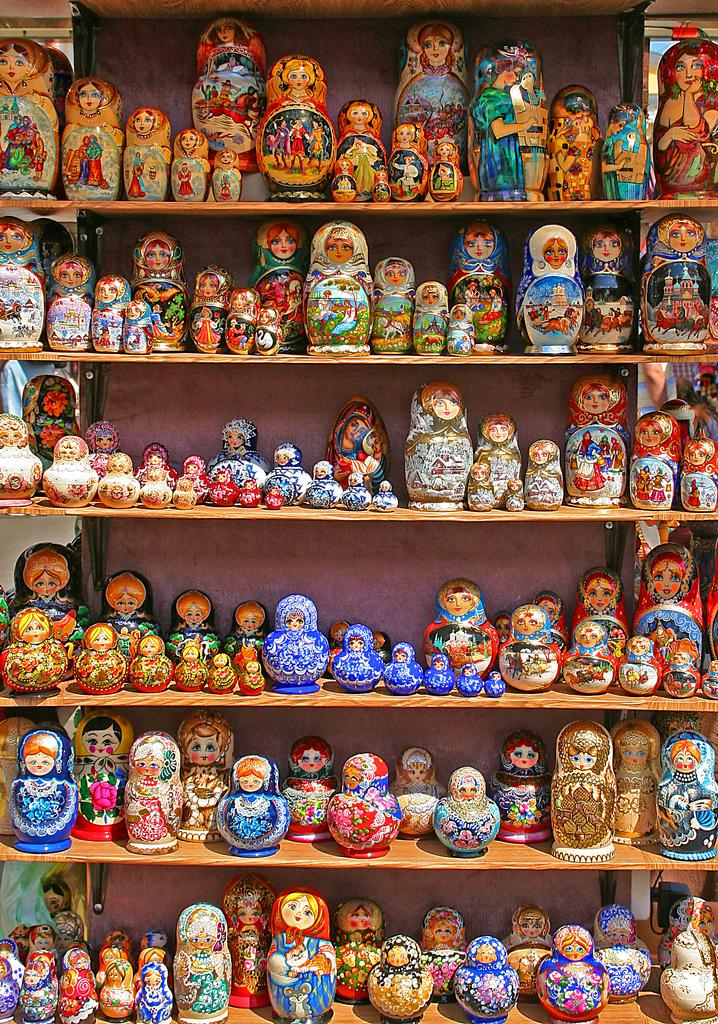What type of objects can be seen in the image? There are toys in the image. How are the toys arranged in the image? The toys are arranged in an order. Where are the toys placed in the image? The toys are placed on racks. What type of desk can be seen in the image? There is no desk present in the image. The toys are placed on racks. 